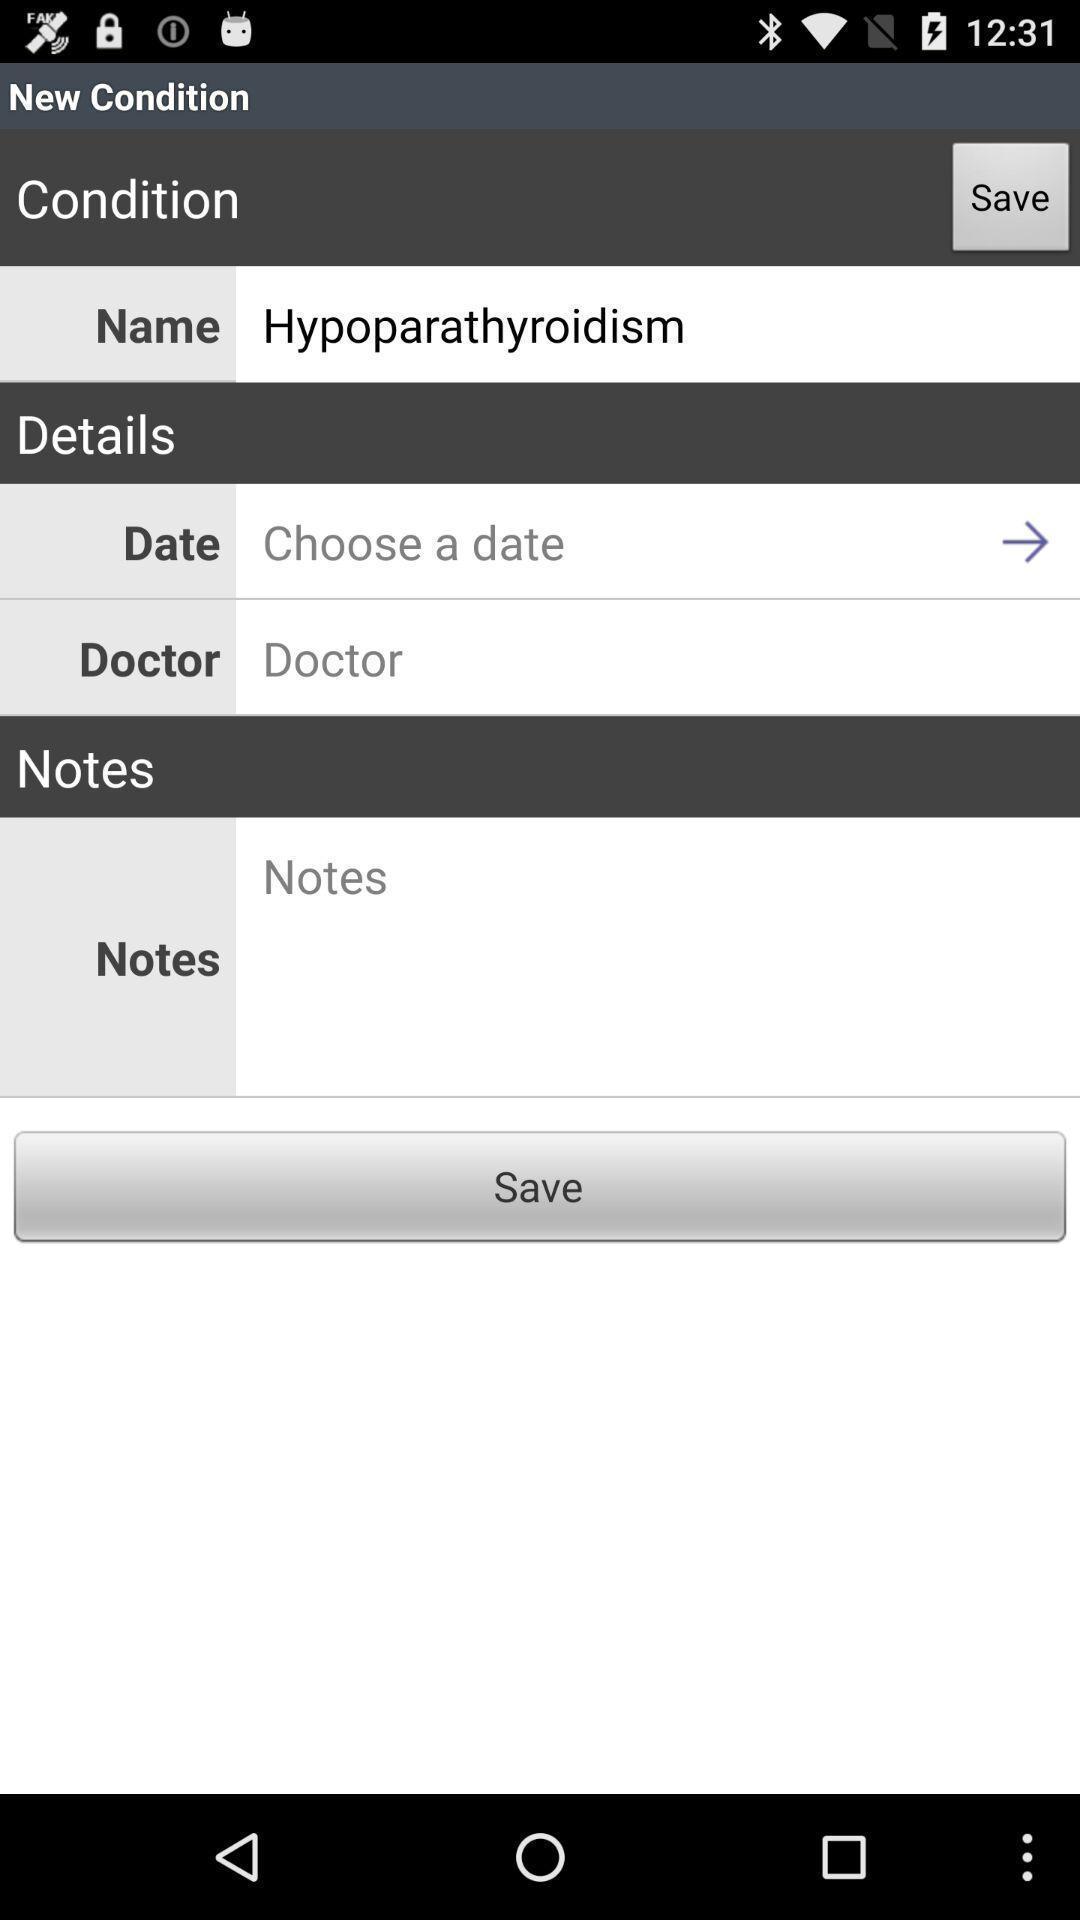Tell me about the visual elements in this screen capture. Screen displaying the page of a medical app. 